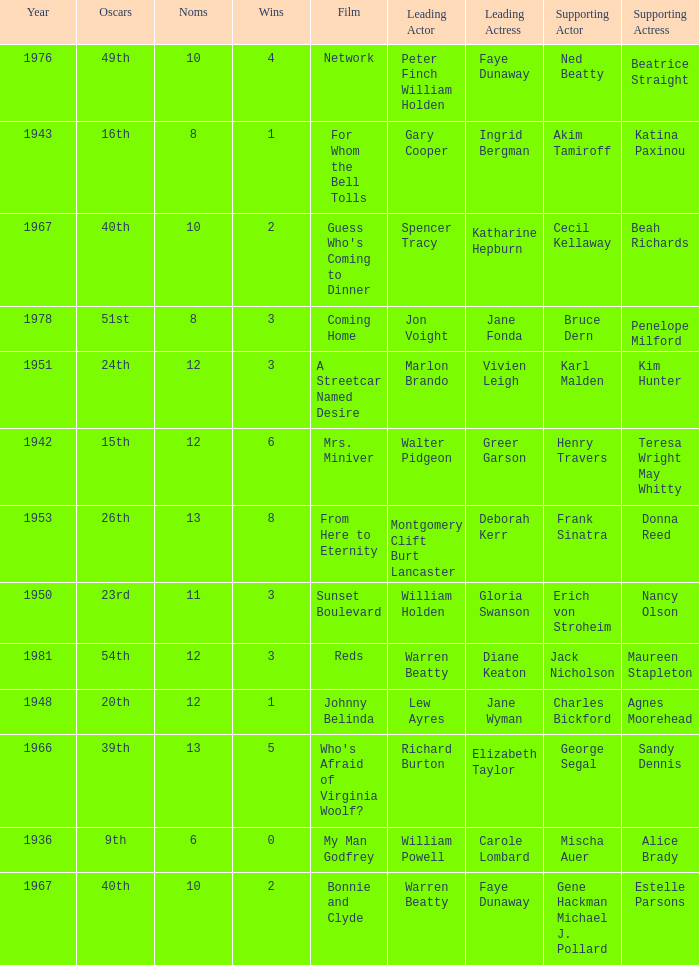Who was the leading actress in a film with Warren Beatty as the leading actor and also at the 40th Oscars? Faye Dunaway. 